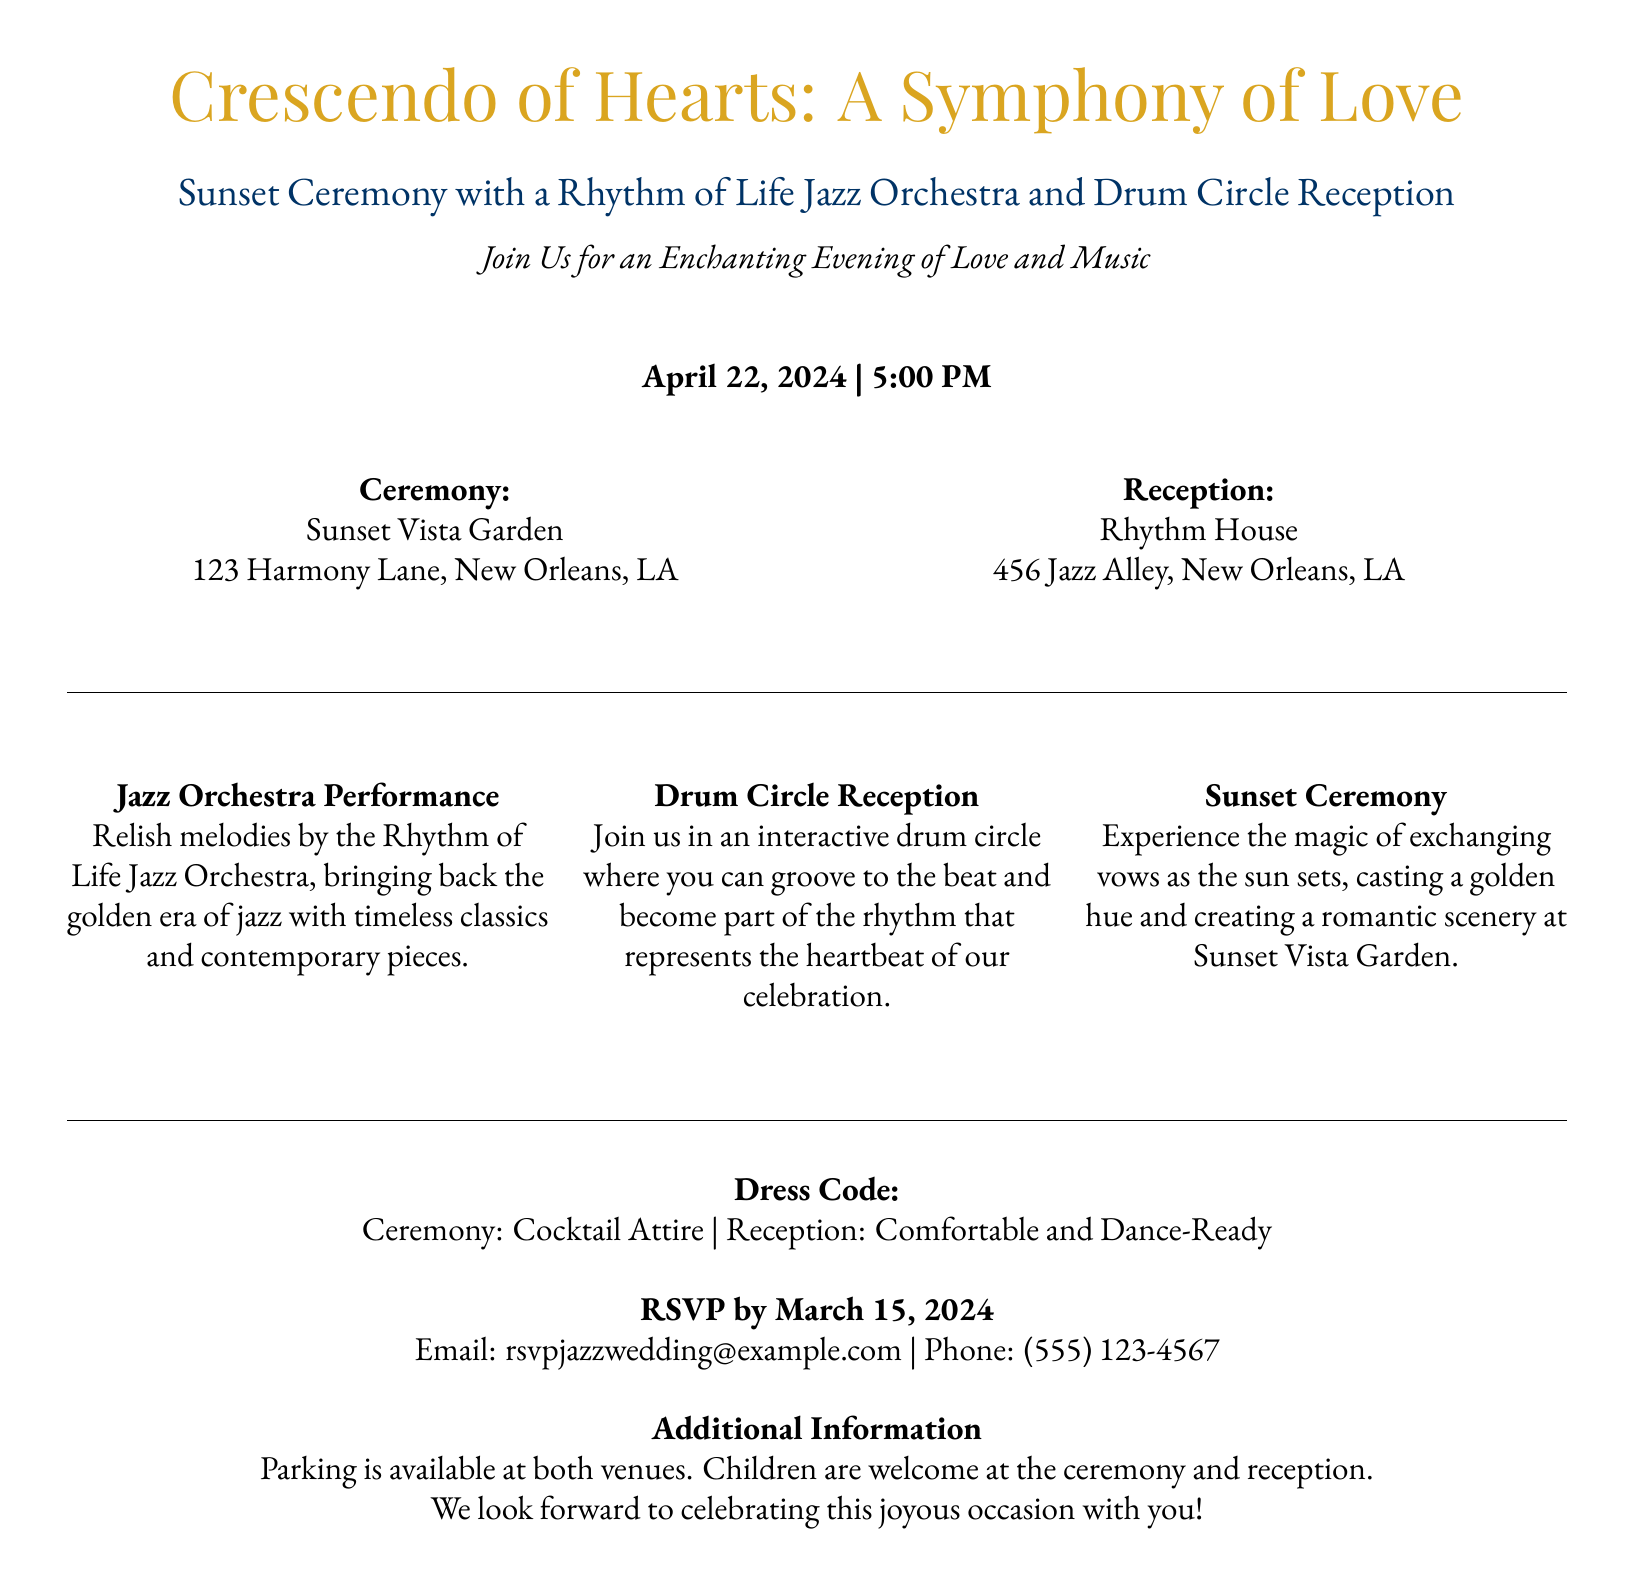What is the date of the wedding? The wedding date is clearly stated in the document as April 22, 2024.
Answer: April 22, 2024 What time does the ceremony start? The ceremony time is provided in the document as 5:00 PM.
Answer: 5:00 PM Where is the ceremony taking place? The location of the ceremony is listed as Sunset Vista Garden, 123 Harmony Lane, New Orleans, LA.
Answer: Sunset Vista Garden What is the dress code for the reception? The dress code for the reception is mentioned as Comfortable and Dance-Ready.
Answer: Comfortable and Dance-Ready When is the RSVP deadline? The RSVP deadline is noted in the document as March 15, 2024.
Answer: March 15, 2024 What kind of music will be played at the reception? The document specifies that the Rhythm of Life Jazz Orchestra will perform, highlighting jazz music.
Answer: Jazz music How many venues are mentioned in the invitation? The document mentions two venues for the wedding events: the ceremony and reception locations.
Answer: Two venues Is there parking available? The document states that parking is available at both venues, indicating convenience for guests.
Answer: Yes Are children allowed at the events? It is clearly mentioned that children are welcome at the ceremony and reception.
Answer: Yes 